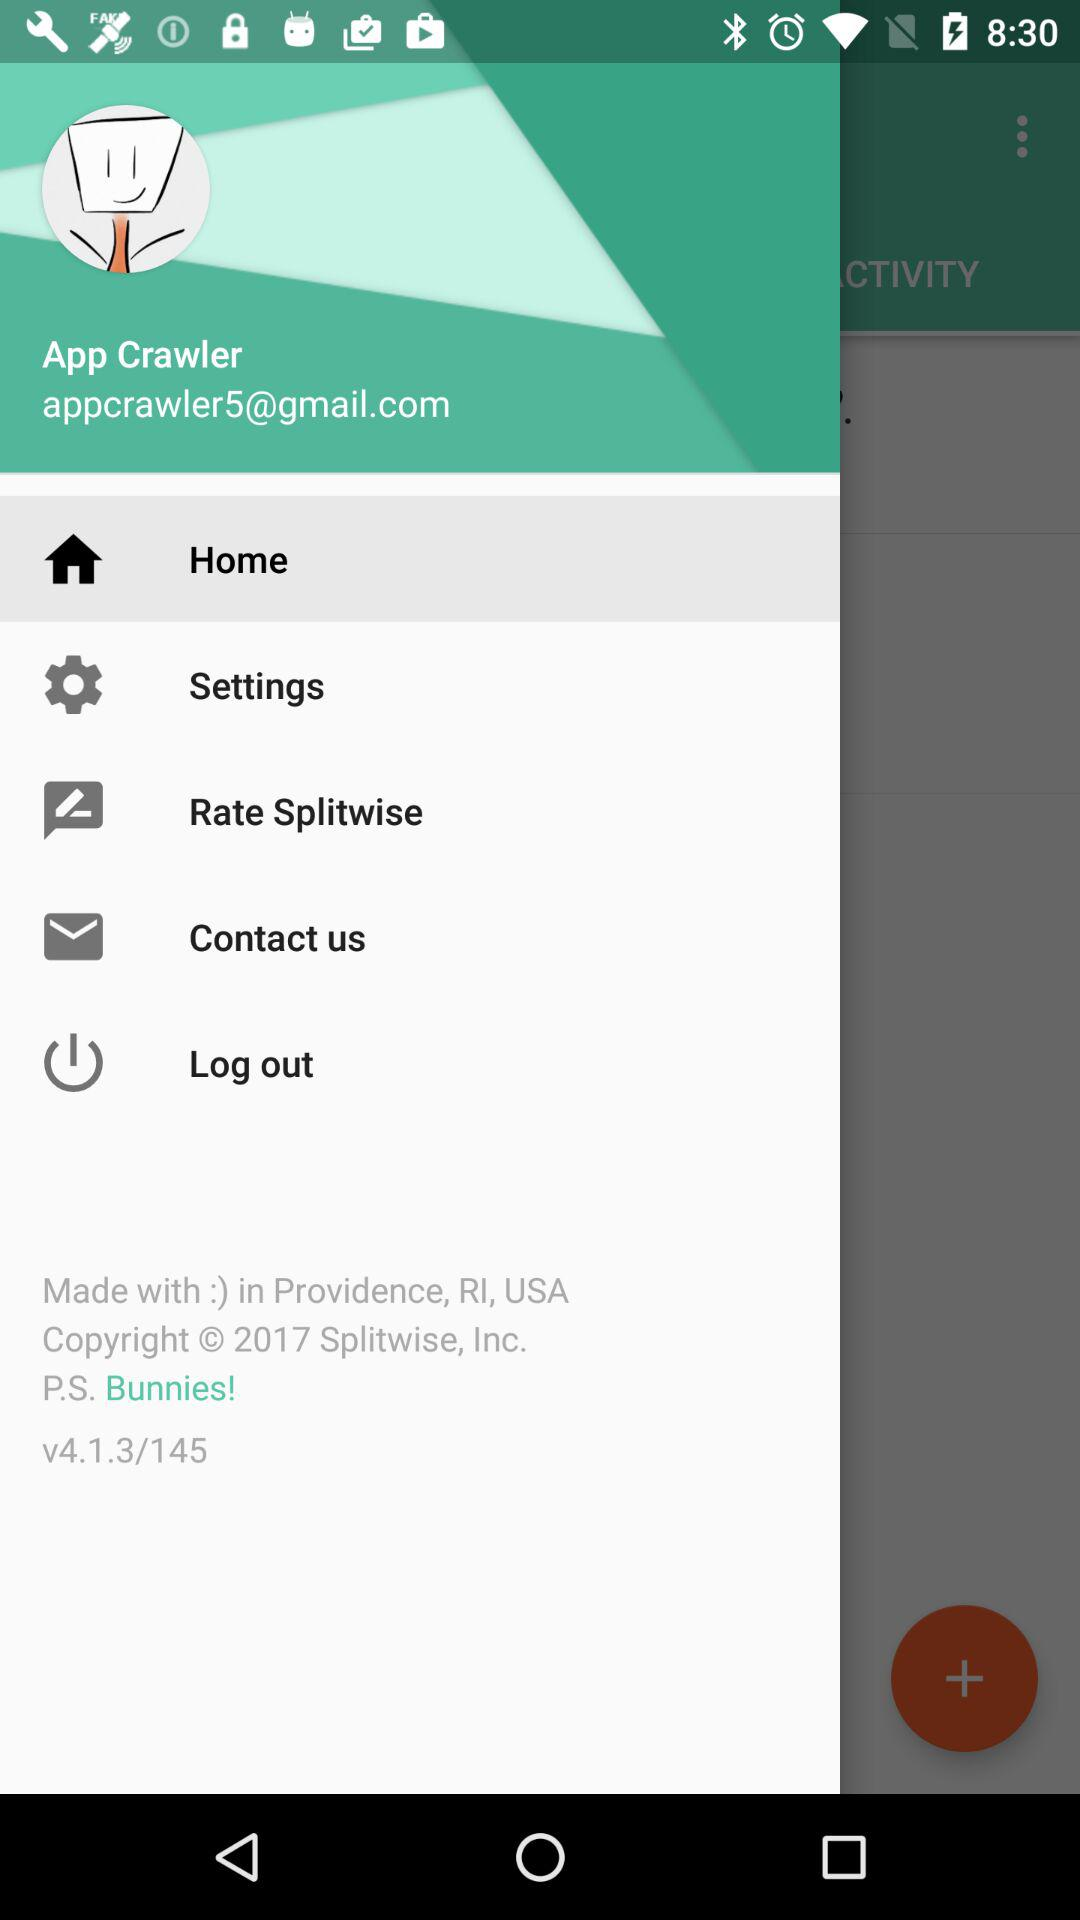What is the email address? The email address is appcrawler5@gmail.com. 